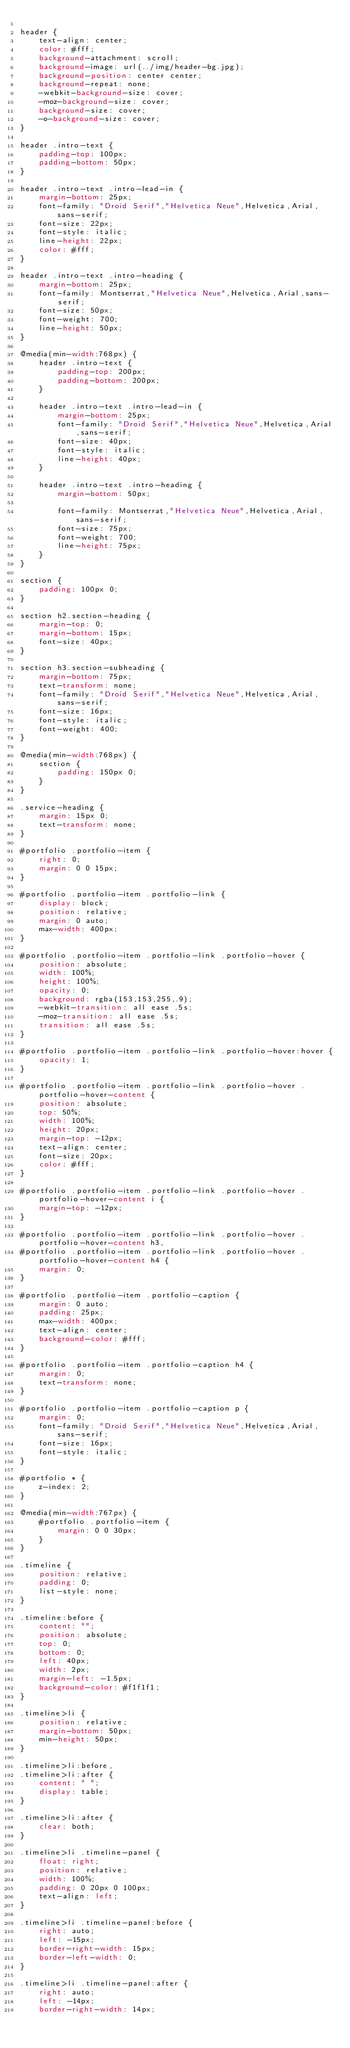<code> <loc_0><loc_0><loc_500><loc_500><_CSS_>
header {
    text-align: center;
    color: #fff;
    background-attachment: scroll;
    background-image: url(../img/header-bg.jpg);
    background-position: center center;
    background-repeat: none;
    -webkit-background-size: cover;
    -moz-background-size: cover;
    background-size: cover;
    -o-background-size: cover;
}

header .intro-text {
    padding-top: 100px;
    padding-bottom: 50px;
}

header .intro-text .intro-lead-in {
    margin-bottom: 25px;
    font-family: "Droid Serif","Helvetica Neue",Helvetica,Arial,sans-serif;
    font-size: 22px;
    font-style: italic;
    line-height: 22px;
    color: #fff;
}

header .intro-text .intro-heading {
    margin-bottom: 25px;
    font-family: Montserrat,"Helvetica Neue",Helvetica,Arial,sans-serif;
    font-size: 50px;
    font-weight: 700;
    line-height: 50px;
}

@media(min-width:768px) {
    header .intro-text {
        padding-top: 200px;
        padding-bottom: 200px;
    }

    header .intro-text .intro-lead-in {
        margin-bottom: 25px;
        font-family: "Droid Serif","Helvetica Neue",Helvetica,Arial,sans-serif;
        font-size: 40px;
        font-style: italic;
        line-height: 40px;
    }

    header .intro-text .intro-heading {
        margin-bottom: 50px;

        font-family: Montserrat,"Helvetica Neue",Helvetica,Arial,sans-serif;
        font-size: 75px;
        font-weight: 700;
        line-height: 75px;
    }
}

section {
    padding: 100px 0;
}

section h2.section-heading {
    margin-top: 0;
    margin-bottom: 15px;
    font-size: 40px;
}

section h3.section-subheading {
    margin-bottom: 75px;
    text-transform: none;
    font-family: "Droid Serif","Helvetica Neue",Helvetica,Arial,sans-serif;
    font-size: 16px;
    font-style: italic;
    font-weight: 400;
}

@media(min-width:768px) {
    section {
        padding: 150px 0;
    }
}

.service-heading {
    margin: 15px 0;
    text-transform: none;
}

#portfolio .portfolio-item {
    right: 0;
    margin: 0 0 15px;
}

#portfolio .portfolio-item .portfolio-link {
    display: block;
    position: relative;
    margin: 0 auto;
    max-width: 400px;
}

#portfolio .portfolio-item .portfolio-link .portfolio-hover {
    position: absolute;
    width: 100%;
    height: 100%;
    opacity: 0;
    background: rgba(153,153,255,.9);
    -webkit-transition: all ease .5s;
    -moz-transition: all ease .5s;
    transition: all ease .5s;
}

#portfolio .portfolio-item .portfolio-link .portfolio-hover:hover {
    opacity: 1;
}

#portfolio .portfolio-item .portfolio-link .portfolio-hover .portfolio-hover-content {
    position: absolute;
    top: 50%;
    width: 100%;
    height: 20px;
    margin-top: -12px;
    text-align: center;
    font-size: 20px;
    color: #fff;
}

#portfolio .portfolio-item .portfolio-link .portfolio-hover .portfolio-hover-content i {
    margin-top: -12px;
}

#portfolio .portfolio-item .portfolio-link .portfolio-hover .portfolio-hover-content h3,
#portfolio .portfolio-item .portfolio-link .portfolio-hover .portfolio-hover-content h4 {
    margin: 0;
}

#portfolio .portfolio-item .portfolio-caption {
    margin: 0 auto;
    padding: 25px;
    max-width: 400px;
    text-align: center;
    background-color: #fff;
}

#portfolio .portfolio-item .portfolio-caption h4 {
    margin: 0;
    text-transform: none;
}

#portfolio .portfolio-item .portfolio-caption p {
    margin: 0;
    font-family: "Droid Serif","Helvetica Neue",Helvetica,Arial,sans-serif;
    font-size: 16px;
    font-style: italic;
}

#portfolio * {
    z-index: 2;
}

@media(min-width:767px) {
    #portfolio .portfolio-item {
        margin: 0 0 30px;
    }
}

.timeline {
    position: relative;
    padding: 0;
    list-style: none;
}

.timeline:before {
    content: "";
    position: absolute;
    top: 0;
    bottom: 0;
    left: 40px;
    width: 2px;
    margin-left: -1.5px;
    background-color: #f1f1f1;
}

.timeline>li {
    position: relative;
    margin-bottom: 50px;
    min-height: 50px;
}

.timeline>li:before,
.timeline>li:after {
    content: " ";
    display: table;
}

.timeline>li:after {
    clear: both;
}

.timeline>li .timeline-panel {
    float: right;
    position: relative;
    width: 100%;
    padding: 0 20px 0 100px;
    text-align: left;
}

.timeline>li .timeline-panel:before {
    right: auto;
    left: -15px;
    border-right-width: 15px;
    border-left-width: 0;
}

.timeline>li .timeline-panel:after {
    right: auto;
    left: -14px;
    border-right-width: 14px;</code> 